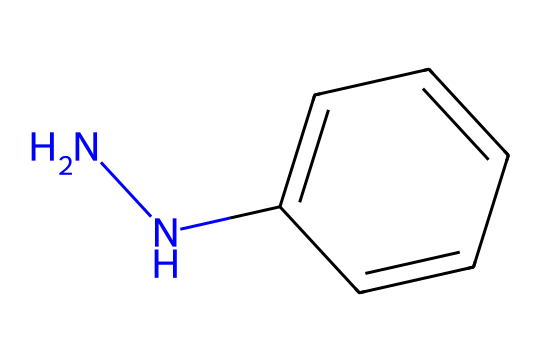what is the molecular formula of phenylhydrazine? The molecular formula can be derived from the SMILES representation by identifying the constituent atoms. The structure contains 6 carbon (C) atoms from the phenyl group, 7 hydrogen (H) atoms total, and 2 nitrogen (N) atoms from the hydrazine component. This gives a total molecular formula of C6H8N2.
Answer: C6H8N2 how many nitrogen atoms are present in phenylhydrazine? The SMILES representation shows that the chemical contains 'NN', indicating two nitrogen atoms linked to each other. Therefore, the total number of nitrogen atoms is 2.
Answer: 2 what type of functional groups are present in phenylhydrazine? From the molecular structure, we can identify the presence of hydrazine (N-N bond) and an aromatic ring (phenyl group). This means the functional groups include the hydrazine and an aromatic ring.
Answer: hydrazine and aromatic which element is bonded to the aromatic ring in phenylhydrazine? The structure shows that the nitrogen atom ('N') from the hydrazine is directly bonded to the aromatic ring (c1ccccc1). This indicates that the only element that bonds to the aromatic ring in this compound is nitrogen.
Answer: nitrogen how does the presence of the nitrogen atoms affect the properties of phenylhydrazine? Nitrogen atoms in hydrazines are known to increase reactivity and affect the properties of the molecule. Specifically, they can participate in redox reactions and cause electrophilic activity due to their lone pairs, enhancing the electrochemical capabilities.
Answer: reactivity what is the significance of phenylhydrazine in electrochemical sensors? Phenylhydrazine is utilized in electrochemical sensors as a redox-active compound that can undergo electron transfer reactions. The electron-rich nitrogen atoms enhance its ability to sense oxidative environments, which is crucial for detecting specific analytes.
Answer: redox-active compound 